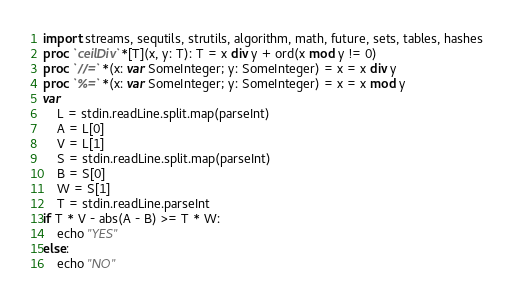Convert code to text. <code><loc_0><loc_0><loc_500><loc_500><_Nim_>import streams, sequtils, strutils, algorithm, math, future, sets, tables, hashes
proc `ceilDiv`*[T](x, y: T): T = x div y + ord(x mod y != 0)
proc `//=`*(x: var SomeInteger; y: SomeInteger) = x = x div y
proc `%=`*(x: var SomeInteger; y: SomeInteger) = x = x mod y
var
    L = stdin.readLine.split.map(parseInt)
    A = L[0]
    V = L[1]
    S = stdin.readLine.split.map(parseInt)
    B = S[0]
    W = S[1]
    T = stdin.readLine.parseInt
if T * V - abs(A - B) >= T * W:
    echo "YES"
else:
    echo "NO"
</code> 